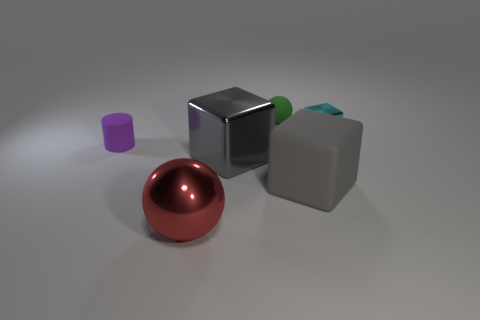What shape is the gray thing that is to the left of the green object?
Offer a terse response. Cube. Are there the same number of big gray objects that are on the right side of the matte cube and big blocks behind the small rubber sphere?
Your response must be concise. Yes. How many things are either small matte cylinders or big gray things that are to the right of the green rubber thing?
Provide a succinct answer. 2. What is the shape of the thing that is both in front of the big gray metallic cube and to the right of the red shiny sphere?
Ensure brevity in your answer.  Cube. There is a sphere that is on the left side of the shiny block in front of the small purple rubber cylinder; what is it made of?
Provide a succinct answer. Metal. Does the ball behind the cyan object have the same material as the purple object?
Give a very brief answer. Yes. There is a rubber thing in front of the small purple thing; what is its size?
Offer a terse response. Large. Are there any cyan things that are right of the sphere that is behind the big red sphere?
Offer a terse response. Yes. Does the big shiny thing that is behind the large red metallic thing have the same color as the rubber thing in front of the tiny purple thing?
Provide a short and direct response. Yes. What is the color of the small cube?
Your answer should be very brief. Cyan. 